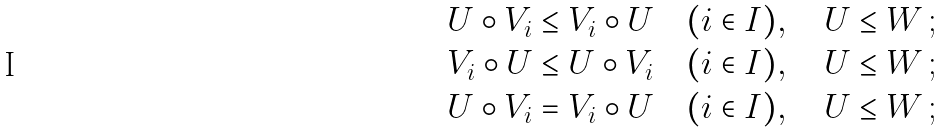Convert formula to latex. <formula><loc_0><loc_0><loc_500><loc_500>& U \circ V _ { i } \leq V _ { i } \circ U \quad ( i \in I ) , \quad U \leq W \, ; \\ & V _ { i } \circ U \leq U \circ V _ { i } \quad ( i \in I ) , \quad U \leq W \, ; \\ & U \circ V _ { i } = V _ { i } \circ U \quad ( i \in I ) , \quad U \leq W \, ;</formula> 